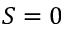Convert formula to latex. <formula><loc_0><loc_0><loc_500><loc_500>S = 0</formula> 